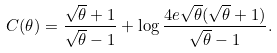Convert formula to latex. <formula><loc_0><loc_0><loc_500><loc_500>C ( \theta ) = \frac { \sqrt { \theta } + 1 } { \sqrt { \theta } - 1 } + \log \frac { 4 e \sqrt { \theta } ( \sqrt { \theta } + 1 ) } { \sqrt { \theta } - 1 } .</formula> 